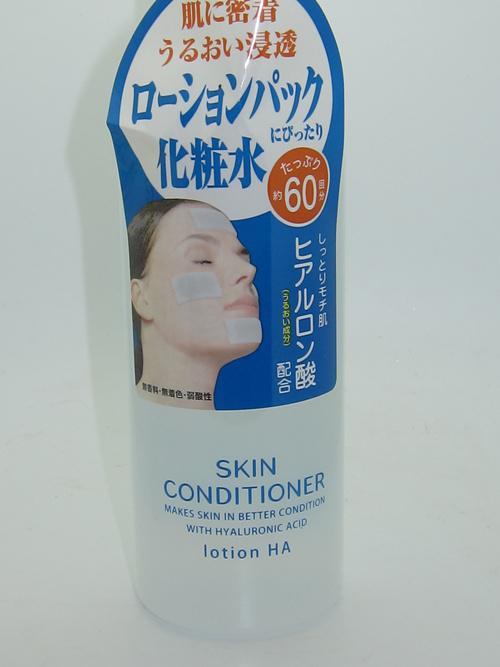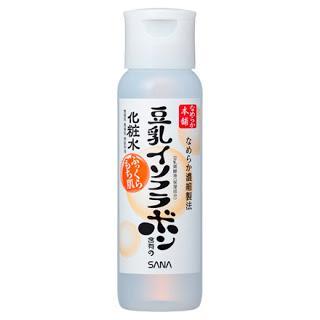The first image is the image on the left, the second image is the image on the right. For the images shown, is this caption "The product on the left is in a pump-top bottle with its nozzle turned leftward, and the product on the right does not have a pump-top." true? Answer yes or no. No. 